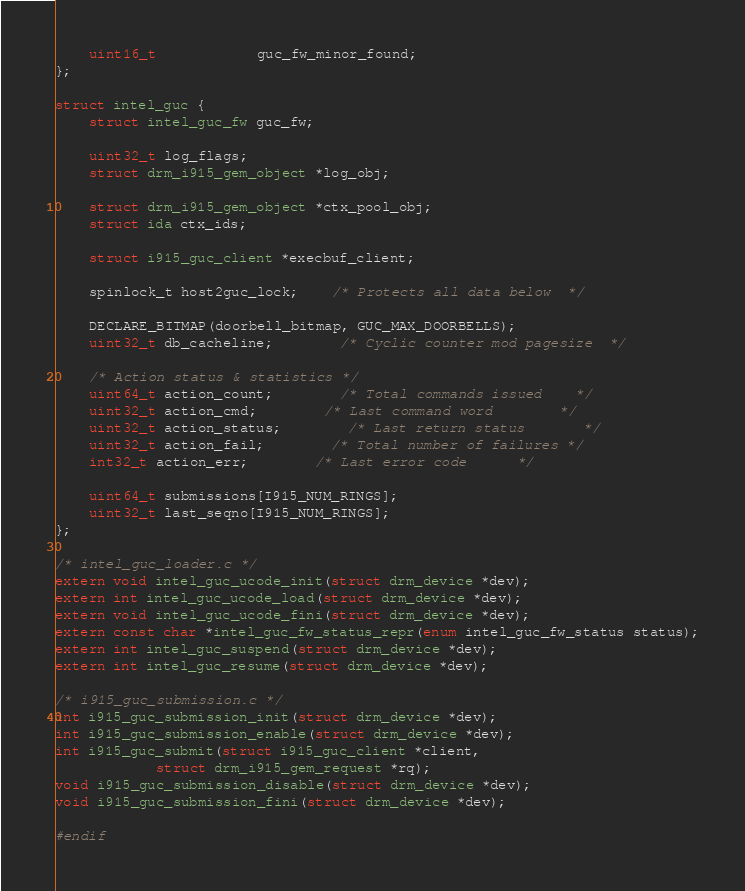<code> <loc_0><loc_0><loc_500><loc_500><_C_>	uint16_t			guc_fw_minor_found;
};

struct intel_guc {
	struct intel_guc_fw guc_fw;

	uint32_t log_flags;
	struct drm_i915_gem_object *log_obj;

	struct drm_i915_gem_object *ctx_pool_obj;
	struct ida ctx_ids;

	struct i915_guc_client *execbuf_client;

	spinlock_t host2guc_lock;	/* Protects all data below	*/

	DECLARE_BITMAP(doorbell_bitmap, GUC_MAX_DOORBELLS);
	uint32_t db_cacheline;		/* Cyclic counter mod pagesize	*/

	/* Action status & statistics */
	uint64_t action_count;		/* Total commands issued	*/
	uint32_t action_cmd;		/* Last command word		*/
	uint32_t action_status;		/* Last return status		*/
	uint32_t action_fail;		/* Total number of failures	*/
	int32_t action_err;		/* Last error code		*/

	uint64_t submissions[I915_NUM_RINGS];
	uint32_t last_seqno[I915_NUM_RINGS];
};

/* intel_guc_loader.c */
extern void intel_guc_ucode_init(struct drm_device *dev);
extern int intel_guc_ucode_load(struct drm_device *dev);
extern void intel_guc_ucode_fini(struct drm_device *dev);
extern const char *intel_guc_fw_status_repr(enum intel_guc_fw_status status);
extern int intel_guc_suspend(struct drm_device *dev);
extern int intel_guc_resume(struct drm_device *dev);

/* i915_guc_submission.c */
int i915_guc_submission_init(struct drm_device *dev);
int i915_guc_submission_enable(struct drm_device *dev);
int i915_guc_submit(struct i915_guc_client *client,
		    struct drm_i915_gem_request *rq);
void i915_guc_submission_disable(struct drm_device *dev);
void i915_guc_submission_fini(struct drm_device *dev);

#endif
</code> 